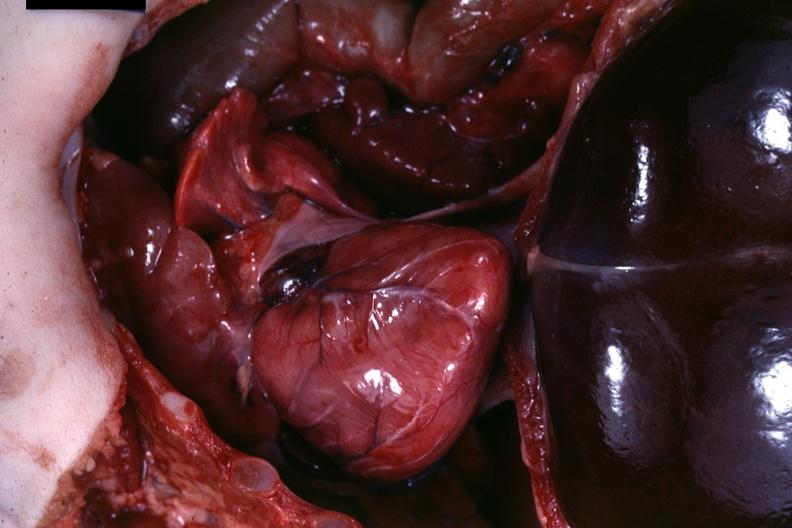s soft tissue present?
Answer the question using a single word or phrase. Yes 